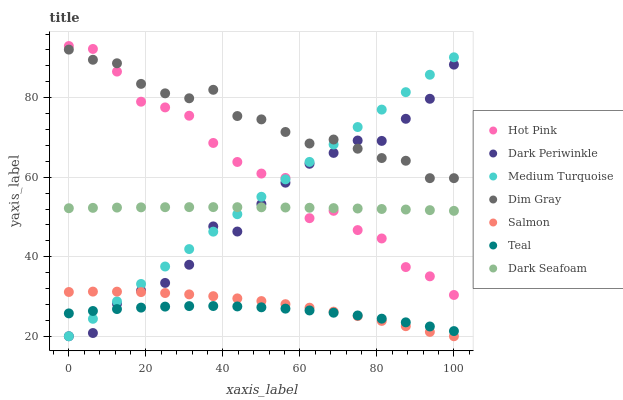Does Teal have the minimum area under the curve?
Answer yes or no. Yes. Does Dim Gray have the maximum area under the curve?
Answer yes or no. Yes. Does Medium Turquoise have the minimum area under the curve?
Answer yes or no. No. Does Medium Turquoise have the maximum area under the curve?
Answer yes or no. No. Is Medium Turquoise the smoothest?
Answer yes or no. Yes. Is Hot Pink the roughest?
Answer yes or no. Yes. Is Hot Pink the smoothest?
Answer yes or no. No. Is Medium Turquoise the roughest?
Answer yes or no. No. Does Medium Turquoise have the lowest value?
Answer yes or no. Yes. Does Hot Pink have the lowest value?
Answer yes or no. No. Does Hot Pink have the highest value?
Answer yes or no. Yes. Does Medium Turquoise have the highest value?
Answer yes or no. No. Is Teal less than Hot Pink?
Answer yes or no. Yes. Is Dim Gray greater than Salmon?
Answer yes or no. Yes. Does Teal intersect Salmon?
Answer yes or no. Yes. Is Teal less than Salmon?
Answer yes or no. No. Is Teal greater than Salmon?
Answer yes or no. No. Does Teal intersect Hot Pink?
Answer yes or no. No. 